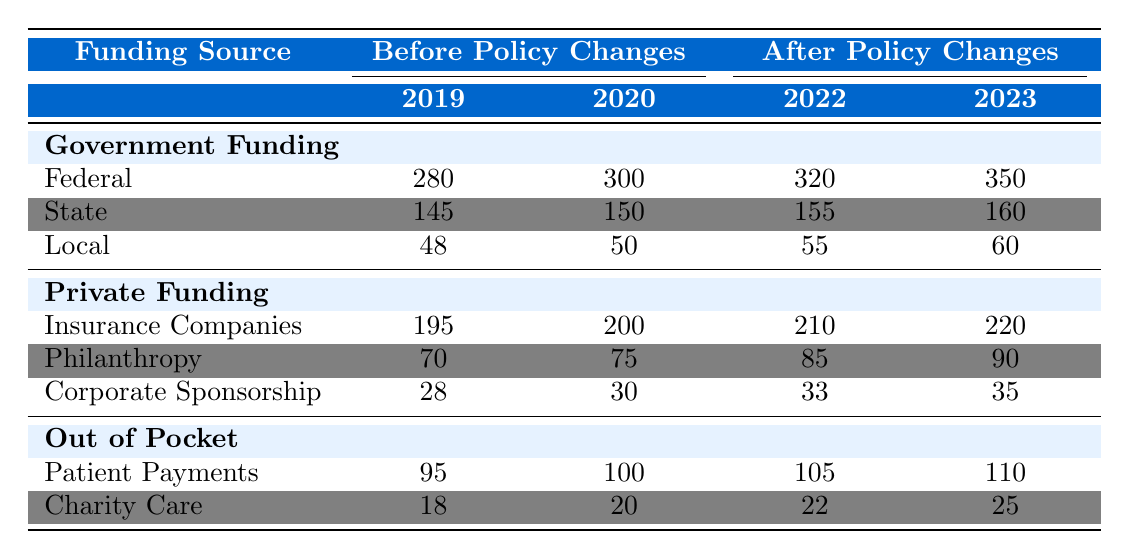What was the total Federal Government funding in 2023? The Federal Government funding in 2023 is listed as 350,000,000.
Answer: 350,000,000 How much did Private Funding from Insurance Companies increase from 2019 to 2023? The funding from Insurance Companies was 195,000,000 in 2019 and increased to 220,000,000 in 2023. The increase is 220,000,000 - 195,000,000 = 25,000,000.
Answer: 25,000,000 Is the Charity Care value higher in 2022 than in 2020? The Charity Care value for 2022 is 22,000,000 and for 2020 it is 20,000,000. Since 22,000,000 > 20,000,000, the statement is true.
Answer: Yes What is the total funding from Out of Pocket sources in 2022? In 2022, the Patient Payments amount to 105,000,000 and Charity Care is 22,000,000. The total is 105,000,000 + 22,000,000 = 127,000,000.
Answer: 127,000,000 Did Local Government funding increase every year from 2019 to 2023? Local Government funding in 2019 was 48,000,000, in 2020 it was 50,000,000, in 2022 it was 55,000,000, and in 2023 it was 60,000,000. Since each year shows a higher value, the statement is true.
Answer: Yes What is the average State Government funding from 2019 to 2023? The values for State Government funding are: 145,000,000 (2019), 150,000,000 (2020), 155,000,000 (2022), and 160,000,000 (2023). The average is (145 + 150 + 155 + 160) / 4 = 152.5 million.
Answer: 152.5 million How much more was spent on Private Funding in 2023 compared to 2022? In 2023, the total for Private Funding (Insurance Companies, Philanthropy, Corporate Sponsorship) is 220,000,000 + 90,000,000 + 35,000,000 = 345,000,000. For 2022, it's 210,000,000 + 85,000,000 + 33,000,000 = 328,000,000. The difference is 345,000,000 - 328,000,000 = 17,000,000.
Answer: 17,000,000 What is the total Government Funding before the policy changes in 2020? In 2020, the Government Funding values are Federal 300,000,000, State 150,000,000, and Local 50,000,000. The total is 300,000,000 + 150,000,000 + 50,000,000 = 500,000,000.
Answer: 500,000,000 In which year was the Corporate Sponsorship funding the lowest? Corporate Sponsorship values are: 28,000,000 (2019), 30,000,000 (2020), 33,000,000 (2022), and 35,000,000 (2023). The lowest value is from 2019.
Answer: 2019 How much did the total Patient Payments increase from 2019 to 2023? Patient Payments in 2019 were 95,000,000 and in 2023 it was 110,000,000. The increase is 110,000,000 - 95,000,000 = 15,000,000.
Answer: 15,000,000 